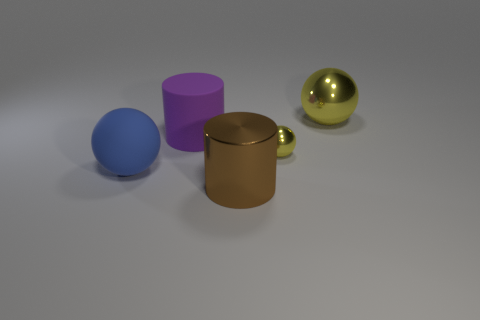What could the objects in the image symbolize if this were an art installation? If interpreted as an art installation, the objects might symbolize a variety of concepts. The purple cylinder could represent industrialization, the blue sphere might evoke the simplicity of nature, the golden sphere could suggest opulence or preciousness, and the brown cube with a handle resembles a mug, which might symbolize daily life or comfort. 